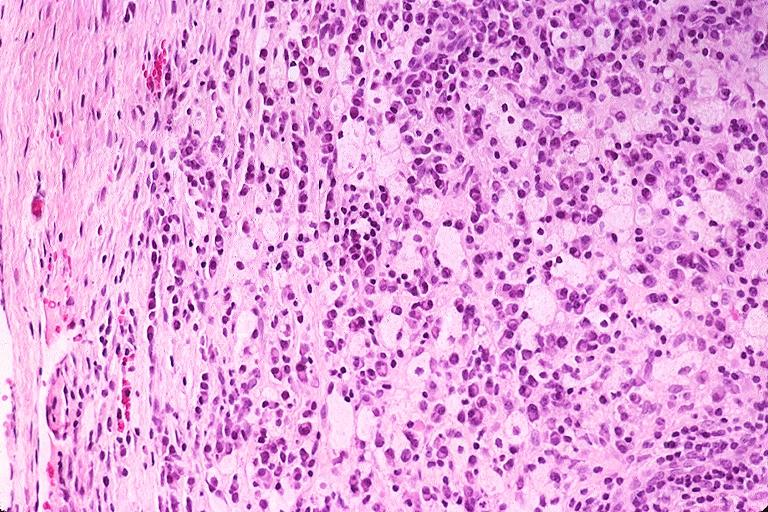what is present?
Answer the question using a single word or phrase. Oral 